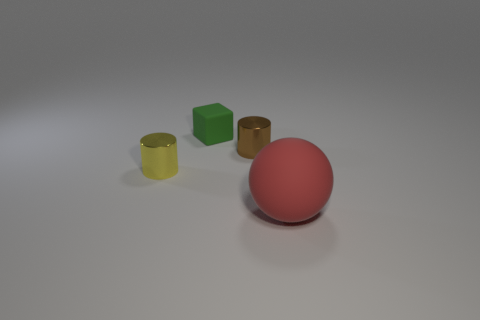Add 4 brown shiny cylinders. How many objects exist? 8 Subtract all spheres. How many objects are left? 3 Subtract 0 cyan balls. How many objects are left? 4 Subtract all large red balls. Subtract all tiny yellow shiny things. How many objects are left? 2 Add 2 yellow metal things. How many yellow metal things are left? 3 Add 1 yellow cylinders. How many yellow cylinders exist? 2 